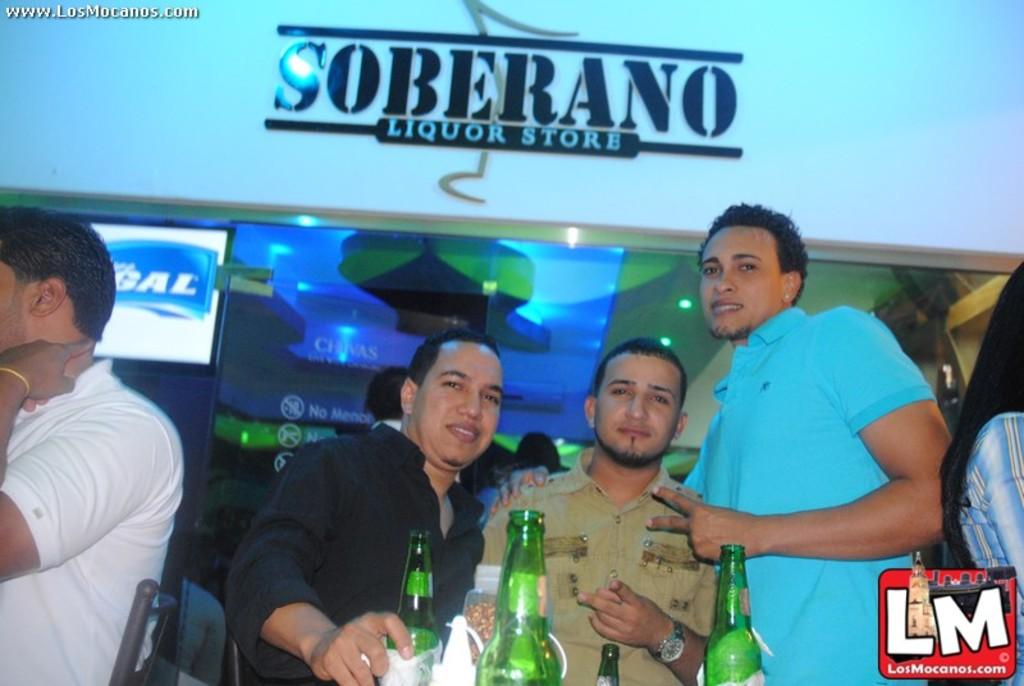What kind of store is this?
Your response must be concise. Liquor. What is the name of this store?
Your answer should be compact. Soberano liquor store. 